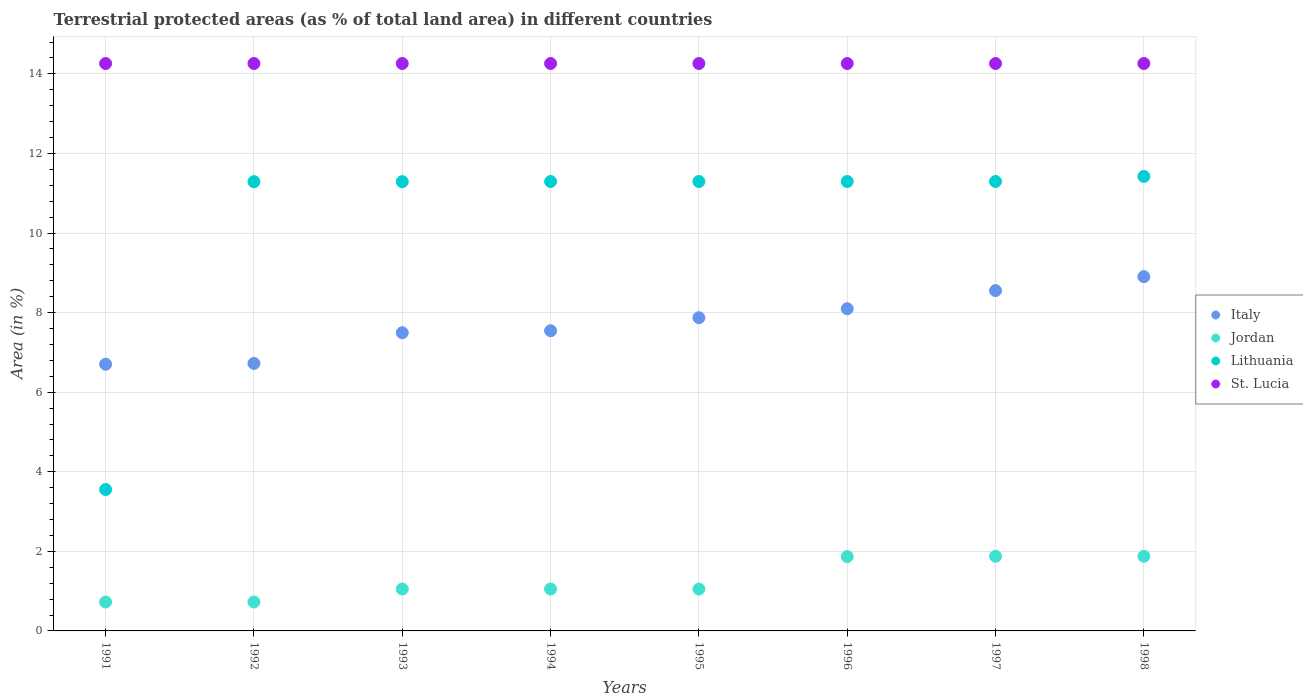How many different coloured dotlines are there?
Your answer should be compact. 4. What is the percentage of terrestrial protected land in Jordan in 1996?
Give a very brief answer. 1.87. Across all years, what is the maximum percentage of terrestrial protected land in St. Lucia?
Ensure brevity in your answer.  14.26. Across all years, what is the minimum percentage of terrestrial protected land in St. Lucia?
Keep it short and to the point. 14.26. In which year was the percentage of terrestrial protected land in Jordan minimum?
Offer a terse response. 1991. What is the total percentage of terrestrial protected land in Italy in the graph?
Give a very brief answer. 61.89. What is the difference between the percentage of terrestrial protected land in St. Lucia in 1991 and that in 1997?
Offer a terse response. 0. What is the difference between the percentage of terrestrial protected land in St. Lucia in 1993 and the percentage of terrestrial protected land in Jordan in 1992?
Provide a short and direct response. 13.53. What is the average percentage of terrestrial protected land in Italy per year?
Give a very brief answer. 7.74. In the year 1996, what is the difference between the percentage of terrestrial protected land in Jordan and percentage of terrestrial protected land in Italy?
Provide a succinct answer. -6.23. What is the ratio of the percentage of terrestrial protected land in Italy in 1992 to that in 1994?
Your response must be concise. 0.89. Is the percentage of terrestrial protected land in St. Lucia in 1991 less than that in 1993?
Offer a terse response. No. What is the difference between the highest and the lowest percentage of terrestrial protected land in Lithuania?
Provide a succinct answer. 7.87. In how many years, is the percentage of terrestrial protected land in Lithuania greater than the average percentage of terrestrial protected land in Lithuania taken over all years?
Offer a terse response. 7. Is the sum of the percentage of terrestrial protected land in St. Lucia in 1991 and 1998 greater than the maximum percentage of terrestrial protected land in Lithuania across all years?
Your response must be concise. Yes. Is it the case that in every year, the sum of the percentage of terrestrial protected land in St. Lucia and percentage of terrestrial protected land in Jordan  is greater than the sum of percentage of terrestrial protected land in Italy and percentage of terrestrial protected land in Lithuania?
Provide a succinct answer. Yes. Is it the case that in every year, the sum of the percentage of terrestrial protected land in Jordan and percentage of terrestrial protected land in Lithuania  is greater than the percentage of terrestrial protected land in St. Lucia?
Your answer should be compact. No. Is the percentage of terrestrial protected land in Jordan strictly greater than the percentage of terrestrial protected land in Italy over the years?
Make the answer very short. No. Is the percentage of terrestrial protected land in St. Lucia strictly less than the percentage of terrestrial protected land in Lithuania over the years?
Provide a succinct answer. No. How many dotlines are there?
Offer a terse response. 4. Are the values on the major ticks of Y-axis written in scientific E-notation?
Ensure brevity in your answer.  No. Does the graph contain any zero values?
Give a very brief answer. No. Does the graph contain grids?
Offer a terse response. Yes. Where does the legend appear in the graph?
Keep it short and to the point. Center right. What is the title of the graph?
Make the answer very short. Terrestrial protected areas (as % of total land area) in different countries. Does "Pakistan" appear as one of the legend labels in the graph?
Offer a terse response. No. What is the label or title of the Y-axis?
Your answer should be very brief. Area (in %). What is the Area (in %) in Italy in 1991?
Your answer should be compact. 6.7. What is the Area (in %) of Jordan in 1991?
Your answer should be compact. 0.73. What is the Area (in %) of Lithuania in 1991?
Provide a short and direct response. 3.55. What is the Area (in %) of St. Lucia in 1991?
Make the answer very short. 14.26. What is the Area (in %) of Italy in 1992?
Ensure brevity in your answer.  6.72. What is the Area (in %) of Jordan in 1992?
Offer a very short reply. 0.73. What is the Area (in %) in Lithuania in 1992?
Your response must be concise. 11.29. What is the Area (in %) in St. Lucia in 1992?
Offer a terse response. 14.26. What is the Area (in %) in Italy in 1993?
Provide a short and direct response. 7.49. What is the Area (in %) of Jordan in 1993?
Keep it short and to the point. 1.05. What is the Area (in %) in Lithuania in 1993?
Provide a succinct answer. 11.29. What is the Area (in %) of St. Lucia in 1993?
Your answer should be very brief. 14.26. What is the Area (in %) in Italy in 1994?
Your answer should be compact. 7.54. What is the Area (in %) in Jordan in 1994?
Make the answer very short. 1.05. What is the Area (in %) of Lithuania in 1994?
Provide a short and direct response. 11.29. What is the Area (in %) of St. Lucia in 1994?
Provide a succinct answer. 14.26. What is the Area (in %) in Italy in 1995?
Offer a very short reply. 7.87. What is the Area (in %) of Jordan in 1995?
Offer a very short reply. 1.05. What is the Area (in %) of Lithuania in 1995?
Offer a terse response. 11.29. What is the Area (in %) in St. Lucia in 1995?
Your answer should be compact. 14.26. What is the Area (in %) in Italy in 1996?
Your answer should be very brief. 8.1. What is the Area (in %) in Jordan in 1996?
Your answer should be compact. 1.87. What is the Area (in %) of Lithuania in 1996?
Offer a very short reply. 11.29. What is the Area (in %) in St. Lucia in 1996?
Your answer should be very brief. 14.26. What is the Area (in %) in Italy in 1997?
Your answer should be compact. 8.55. What is the Area (in %) of Jordan in 1997?
Provide a succinct answer. 1.88. What is the Area (in %) in Lithuania in 1997?
Provide a short and direct response. 11.29. What is the Area (in %) of St. Lucia in 1997?
Your response must be concise. 14.26. What is the Area (in %) of Italy in 1998?
Offer a terse response. 8.9. What is the Area (in %) in Jordan in 1998?
Keep it short and to the point. 1.88. What is the Area (in %) of Lithuania in 1998?
Your answer should be compact. 11.42. What is the Area (in %) in St. Lucia in 1998?
Offer a terse response. 14.26. Across all years, what is the maximum Area (in %) of Italy?
Offer a terse response. 8.9. Across all years, what is the maximum Area (in %) of Jordan?
Your response must be concise. 1.88. Across all years, what is the maximum Area (in %) in Lithuania?
Your response must be concise. 11.42. Across all years, what is the maximum Area (in %) in St. Lucia?
Offer a terse response. 14.26. Across all years, what is the minimum Area (in %) of Italy?
Ensure brevity in your answer.  6.7. Across all years, what is the minimum Area (in %) in Jordan?
Provide a succinct answer. 0.73. Across all years, what is the minimum Area (in %) of Lithuania?
Your answer should be very brief. 3.55. Across all years, what is the minimum Area (in %) of St. Lucia?
Offer a terse response. 14.26. What is the total Area (in %) in Italy in the graph?
Make the answer very short. 61.89. What is the total Area (in %) of Jordan in the graph?
Your answer should be compact. 10.23. What is the total Area (in %) of Lithuania in the graph?
Your answer should be very brief. 82.73. What is the total Area (in %) of St. Lucia in the graph?
Provide a succinct answer. 114.08. What is the difference between the Area (in %) of Italy in 1991 and that in 1992?
Make the answer very short. -0.02. What is the difference between the Area (in %) of Jordan in 1991 and that in 1992?
Make the answer very short. 0. What is the difference between the Area (in %) in Lithuania in 1991 and that in 1992?
Give a very brief answer. -7.74. What is the difference between the Area (in %) in Italy in 1991 and that in 1993?
Your answer should be very brief. -0.79. What is the difference between the Area (in %) in Jordan in 1991 and that in 1993?
Provide a succinct answer. -0.33. What is the difference between the Area (in %) in Lithuania in 1991 and that in 1993?
Keep it short and to the point. -7.74. What is the difference between the Area (in %) in St. Lucia in 1991 and that in 1993?
Your response must be concise. 0. What is the difference between the Area (in %) in Italy in 1991 and that in 1994?
Make the answer very short. -0.84. What is the difference between the Area (in %) in Jordan in 1991 and that in 1994?
Provide a short and direct response. -0.33. What is the difference between the Area (in %) in Lithuania in 1991 and that in 1994?
Your answer should be very brief. -7.74. What is the difference between the Area (in %) in Italy in 1991 and that in 1995?
Your answer should be very brief. -1.17. What is the difference between the Area (in %) in Jordan in 1991 and that in 1995?
Keep it short and to the point. -0.33. What is the difference between the Area (in %) in Lithuania in 1991 and that in 1995?
Provide a short and direct response. -7.74. What is the difference between the Area (in %) in Italy in 1991 and that in 1996?
Offer a very short reply. -1.39. What is the difference between the Area (in %) of Jordan in 1991 and that in 1996?
Offer a terse response. -1.14. What is the difference between the Area (in %) of Lithuania in 1991 and that in 1996?
Offer a very short reply. -7.74. What is the difference between the Area (in %) in St. Lucia in 1991 and that in 1996?
Offer a very short reply. 0. What is the difference between the Area (in %) of Italy in 1991 and that in 1997?
Give a very brief answer. -1.85. What is the difference between the Area (in %) of Jordan in 1991 and that in 1997?
Your answer should be very brief. -1.15. What is the difference between the Area (in %) of Lithuania in 1991 and that in 1997?
Provide a succinct answer. -7.74. What is the difference between the Area (in %) of Italy in 1991 and that in 1998?
Your answer should be compact. -2.2. What is the difference between the Area (in %) of Jordan in 1991 and that in 1998?
Your answer should be very brief. -1.15. What is the difference between the Area (in %) in Lithuania in 1991 and that in 1998?
Make the answer very short. -7.87. What is the difference between the Area (in %) in St. Lucia in 1991 and that in 1998?
Offer a terse response. 0. What is the difference between the Area (in %) of Italy in 1992 and that in 1993?
Make the answer very short. -0.77. What is the difference between the Area (in %) in Jordan in 1992 and that in 1993?
Keep it short and to the point. -0.33. What is the difference between the Area (in %) in St. Lucia in 1992 and that in 1993?
Offer a terse response. 0. What is the difference between the Area (in %) of Italy in 1992 and that in 1994?
Offer a very short reply. -0.82. What is the difference between the Area (in %) in Jordan in 1992 and that in 1994?
Keep it short and to the point. -0.33. What is the difference between the Area (in %) in Lithuania in 1992 and that in 1994?
Your response must be concise. -0. What is the difference between the Area (in %) in St. Lucia in 1992 and that in 1994?
Provide a short and direct response. 0. What is the difference between the Area (in %) of Italy in 1992 and that in 1995?
Provide a succinct answer. -1.15. What is the difference between the Area (in %) of Jordan in 1992 and that in 1995?
Provide a succinct answer. -0.33. What is the difference between the Area (in %) in Lithuania in 1992 and that in 1995?
Your answer should be compact. -0. What is the difference between the Area (in %) of St. Lucia in 1992 and that in 1995?
Give a very brief answer. 0. What is the difference between the Area (in %) of Italy in 1992 and that in 1996?
Provide a succinct answer. -1.37. What is the difference between the Area (in %) in Jordan in 1992 and that in 1996?
Provide a succinct answer. -1.14. What is the difference between the Area (in %) in Lithuania in 1992 and that in 1996?
Offer a terse response. -0. What is the difference between the Area (in %) in St. Lucia in 1992 and that in 1996?
Offer a very short reply. 0. What is the difference between the Area (in %) of Italy in 1992 and that in 1997?
Offer a very short reply. -1.83. What is the difference between the Area (in %) of Jordan in 1992 and that in 1997?
Give a very brief answer. -1.15. What is the difference between the Area (in %) in Lithuania in 1992 and that in 1997?
Offer a terse response. -0. What is the difference between the Area (in %) of Italy in 1992 and that in 1998?
Your answer should be compact. -2.18. What is the difference between the Area (in %) in Jordan in 1992 and that in 1998?
Your answer should be compact. -1.15. What is the difference between the Area (in %) in Lithuania in 1992 and that in 1998?
Provide a short and direct response. -0.13. What is the difference between the Area (in %) of Italy in 1993 and that in 1994?
Your answer should be very brief. -0.05. What is the difference between the Area (in %) of Jordan in 1993 and that in 1994?
Provide a short and direct response. 0. What is the difference between the Area (in %) in Lithuania in 1993 and that in 1994?
Your answer should be very brief. -0. What is the difference between the Area (in %) of Italy in 1993 and that in 1995?
Your answer should be very brief. -0.38. What is the difference between the Area (in %) in Jordan in 1993 and that in 1995?
Your response must be concise. 0. What is the difference between the Area (in %) in Lithuania in 1993 and that in 1995?
Give a very brief answer. -0. What is the difference between the Area (in %) of St. Lucia in 1993 and that in 1995?
Make the answer very short. 0. What is the difference between the Area (in %) in Italy in 1993 and that in 1996?
Offer a very short reply. -0.6. What is the difference between the Area (in %) of Jordan in 1993 and that in 1996?
Your answer should be very brief. -0.82. What is the difference between the Area (in %) in Lithuania in 1993 and that in 1996?
Provide a short and direct response. -0. What is the difference between the Area (in %) in Italy in 1993 and that in 1997?
Make the answer very short. -1.06. What is the difference between the Area (in %) of Jordan in 1993 and that in 1997?
Provide a succinct answer. -0.82. What is the difference between the Area (in %) of Lithuania in 1993 and that in 1997?
Make the answer very short. -0. What is the difference between the Area (in %) in Italy in 1993 and that in 1998?
Your answer should be compact. -1.41. What is the difference between the Area (in %) of Jordan in 1993 and that in 1998?
Ensure brevity in your answer.  -0.82. What is the difference between the Area (in %) in Lithuania in 1993 and that in 1998?
Keep it short and to the point. -0.13. What is the difference between the Area (in %) in St. Lucia in 1993 and that in 1998?
Offer a terse response. 0. What is the difference between the Area (in %) of Italy in 1994 and that in 1995?
Offer a terse response. -0.33. What is the difference between the Area (in %) in Jordan in 1994 and that in 1995?
Ensure brevity in your answer.  0. What is the difference between the Area (in %) of Lithuania in 1994 and that in 1995?
Provide a short and direct response. 0. What is the difference between the Area (in %) in St. Lucia in 1994 and that in 1995?
Your answer should be very brief. 0. What is the difference between the Area (in %) in Italy in 1994 and that in 1996?
Keep it short and to the point. -0.55. What is the difference between the Area (in %) in Jordan in 1994 and that in 1996?
Ensure brevity in your answer.  -0.82. What is the difference between the Area (in %) of Lithuania in 1994 and that in 1996?
Offer a very short reply. 0. What is the difference between the Area (in %) in St. Lucia in 1994 and that in 1996?
Offer a terse response. 0. What is the difference between the Area (in %) of Italy in 1994 and that in 1997?
Provide a short and direct response. -1.01. What is the difference between the Area (in %) in Jordan in 1994 and that in 1997?
Offer a terse response. -0.82. What is the difference between the Area (in %) of Lithuania in 1994 and that in 1997?
Offer a very short reply. 0. What is the difference between the Area (in %) of St. Lucia in 1994 and that in 1997?
Ensure brevity in your answer.  0. What is the difference between the Area (in %) of Italy in 1994 and that in 1998?
Make the answer very short. -1.36. What is the difference between the Area (in %) in Jordan in 1994 and that in 1998?
Offer a terse response. -0.82. What is the difference between the Area (in %) in Lithuania in 1994 and that in 1998?
Your answer should be very brief. -0.13. What is the difference between the Area (in %) in St. Lucia in 1994 and that in 1998?
Provide a short and direct response. 0. What is the difference between the Area (in %) in Italy in 1995 and that in 1996?
Your answer should be very brief. -0.23. What is the difference between the Area (in %) of Jordan in 1995 and that in 1996?
Give a very brief answer. -0.82. What is the difference between the Area (in %) of Lithuania in 1995 and that in 1996?
Make the answer very short. 0. What is the difference between the Area (in %) in Italy in 1995 and that in 1997?
Provide a short and direct response. -0.68. What is the difference between the Area (in %) of Jordan in 1995 and that in 1997?
Provide a succinct answer. -0.82. What is the difference between the Area (in %) in Lithuania in 1995 and that in 1997?
Ensure brevity in your answer.  0. What is the difference between the Area (in %) in Italy in 1995 and that in 1998?
Give a very brief answer. -1.03. What is the difference between the Area (in %) of Jordan in 1995 and that in 1998?
Keep it short and to the point. -0.82. What is the difference between the Area (in %) of Lithuania in 1995 and that in 1998?
Your response must be concise. -0.13. What is the difference between the Area (in %) of St. Lucia in 1995 and that in 1998?
Your response must be concise. 0. What is the difference between the Area (in %) of Italy in 1996 and that in 1997?
Keep it short and to the point. -0.46. What is the difference between the Area (in %) of Jordan in 1996 and that in 1997?
Your response must be concise. -0.01. What is the difference between the Area (in %) of Lithuania in 1996 and that in 1997?
Provide a succinct answer. -0. What is the difference between the Area (in %) of St. Lucia in 1996 and that in 1997?
Provide a succinct answer. 0. What is the difference between the Area (in %) in Italy in 1996 and that in 1998?
Your answer should be very brief. -0.81. What is the difference between the Area (in %) of Jordan in 1996 and that in 1998?
Offer a very short reply. -0.01. What is the difference between the Area (in %) in Lithuania in 1996 and that in 1998?
Make the answer very short. -0.13. What is the difference between the Area (in %) in St. Lucia in 1996 and that in 1998?
Ensure brevity in your answer.  0. What is the difference between the Area (in %) of Italy in 1997 and that in 1998?
Offer a very short reply. -0.35. What is the difference between the Area (in %) of Jordan in 1997 and that in 1998?
Ensure brevity in your answer.  0. What is the difference between the Area (in %) of Lithuania in 1997 and that in 1998?
Give a very brief answer. -0.13. What is the difference between the Area (in %) of St. Lucia in 1997 and that in 1998?
Your answer should be compact. 0. What is the difference between the Area (in %) in Italy in 1991 and the Area (in %) in Jordan in 1992?
Your answer should be very brief. 5.98. What is the difference between the Area (in %) in Italy in 1991 and the Area (in %) in Lithuania in 1992?
Provide a succinct answer. -4.59. What is the difference between the Area (in %) in Italy in 1991 and the Area (in %) in St. Lucia in 1992?
Provide a short and direct response. -7.56. What is the difference between the Area (in %) in Jordan in 1991 and the Area (in %) in Lithuania in 1992?
Ensure brevity in your answer.  -10.56. What is the difference between the Area (in %) of Jordan in 1991 and the Area (in %) of St. Lucia in 1992?
Your answer should be very brief. -13.53. What is the difference between the Area (in %) in Lithuania in 1991 and the Area (in %) in St. Lucia in 1992?
Give a very brief answer. -10.71. What is the difference between the Area (in %) in Italy in 1991 and the Area (in %) in Jordan in 1993?
Give a very brief answer. 5.65. What is the difference between the Area (in %) of Italy in 1991 and the Area (in %) of Lithuania in 1993?
Offer a very short reply. -4.59. What is the difference between the Area (in %) of Italy in 1991 and the Area (in %) of St. Lucia in 1993?
Keep it short and to the point. -7.56. What is the difference between the Area (in %) in Jordan in 1991 and the Area (in %) in Lithuania in 1993?
Your response must be concise. -10.56. What is the difference between the Area (in %) of Jordan in 1991 and the Area (in %) of St. Lucia in 1993?
Provide a succinct answer. -13.53. What is the difference between the Area (in %) in Lithuania in 1991 and the Area (in %) in St. Lucia in 1993?
Offer a terse response. -10.71. What is the difference between the Area (in %) in Italy in 1991 and the Area (in %) in Jordan in 1994?
Offer a terse response. 5.65. What is the difference between the Area (in %) of Italy in 1991 and the Area (in %) of Lithuania in 1994?
Give a very brief answer. -4.59. What is the difference between the Area (in %) of Italy in 1991 and the Area (in %) of St. Lucia in 1994?
Provide a short and direct response. -7.56. What is the difference between the Area (in %) in Jordan in 1991 and the Area (in %) in Lithuania in 1994?
Provide a short and direct response. -10.57. What is the difference between the Area (in %) of Jordan in 1991 and the Area (in %) of St. Lucia in 1994?
Your answer should be very brief. -13.53. What is the difference between the Area (in %) in Lithuania in 1991 and the Area (in %) in St. Lucia in 1994?
Keep it short and to the point. -10.71. What is the difference between the Area (in %) in Italy in 1991 and the Area (in %) in Jordan in 1995?
Offer a terse response. 5.65. What is the difference between the Area (in %) in Italy in 1991 and the Area (in %) in Lithuania in 1995?
Ensure brevity in your answer.  -4.59. What is the difference between the Area (in %) in Italy in 1991 and the Area (in %) in St. Lucia in 1995?
Make the answer very short. -7.56. What is the difference between the Area (in %) of Jordan in 1991 and the Area (in %) of Lithuania in 1995?
Keep it short and to the point. -10.57. What is the difference between the Area (in %) in Jordan in 1991 and the Area (in %) in St. Lucia in 1995?
Provide a short and direct response. -13.53. What is the difference between the Area (in %) of Lithuania in 1991 and the Area (in %) of St. Lucia in 1995?
Ensure brevity in your answer.  -10.71. What is the difference between the Area (in %) of Italy in 1991 and the Area (in %) of Jordan in 1996?
Your answer should be compact. 4.83. What is the difference between the Area (in %) in Italy in 1991 and the Area (in %) in Lithuania in 1996?
Make the answer very short. -4.59. What is the difference between the Area (in %) of Italy in 1991 and the Area (in %) of St. Lucia in 1996?
Offer a very short reply. -7.56. What is the difference between the Area (in %) of Jordan in 1991 and the Area (in %) of Lithuania in 1996?
Provide a succinct answer. -10.57. What is the difference between the Area (in %) in Jordan in 1991 and the Area (in %) in St. Lucia in 1996?
Your response must be concise. -13.53. What is the difference between the Area (in %) in Lithuania in 1991 and the Area (in %) in St. Lucia in 1996?
Give a very brief answer. -10.71. What is the difference between the Area (in %) in Italy in 1991 and the Area (in %) in Jordan in 1997?
Provide a short and direct response. 4.83. What is the difference between the Area (in %) of Italy in 1991 and the Area (in %) of Lithuania in 1997?
Offer a very short reply. -4.59. What is the difference between the Area (in %) in Italy in 1991 and the Area (in %) in St. Lucia in 1997?
Ensure brevity in your answer.  -7.56. What is the difference between the Area (in %) in Jordan in 1991 and the Area (in %) in Lithuania in 1997?
Your response must be concise. -10.57. What is the difference between the Area (in %) in Jordan in 1991 and the Area (in %) in St. Lucia in 1997?
Provide a succinct answer. -13.53. What is the difference between the Area (in %) of Lithuania in 1991 and the Area (in %) of St. Lucia in 1997?
Offer a very short reply. -10.71. What is the difference between the Area (in %) of Italy in 1991 and the Area (in %) of Jordan in 1998?
Keep it short and to the point. 4.83. What is the difference between the Area (in %) of Italy in 1991 and the Area (in %) of Lithuania in 1998?
Provide a succinct answer. -4.72. What is the difference between the Area (in %) of Italy in 1991 and the Area (in %) of St. Lucia in 1998?
Provide a short and direct response. -7.56. What is the difference between the Area (in %) of Jordan in 1991 and the Area (in %) of Lithuania in 1998?
Your response must be concise. -10.69. What is the difference between the Area (in %) of Jordan in 1991 and the Area (in %) of St. Lucia in 1998?
Your answer should be very brief. -13.53. What is the difference between the Area (in %) in Lithuania in 1991 and the Area (in %) in St. Lucia in 1998?
Make the answer very short. -10.71. What is the difference between the Area (in %) of Italy in 1992 and the Area (in %) of Jordan in 1993?
Your answer should be very brief. 5.67. What is the difference between the Area (in %) in Italy in 1992 and the Area (in %) in Lithuania in 1993?
Provide a succinct answer. -4.57. What is the difference between the Area (in %) in Italy in 1992 and the Area (in %) in St. Lucia in 1993?
Ensure brevity in your answer.  -7.54. What is the difference between the Area (in %) of Jordan in 1992 and the Area (in %) of Lithuania in 1993?
Your answer should be very brief. -10.56. What is the difference between the Area (in %) in Jordan in 1992 and the Area (in %) in St. Lucia in 1993?
Give a very brief answer. -13.53. What is the difference between the Area (in %) of Lithuania in 1992 and the Area (in %) of St. Lucia in 1993?
Your answer should be very brief. -2.97. What is the difference between the Area (in %) in Italy in 1992 and the Area (in %) in Jordan in 1994?
Your answer should be compact. 5.67. What is the difference between the Area (in %) in Italy in 1992 and the Area (in %) in Lithuania in 1994?
Provide a succinct answer. -4.57. What is the difference between the Area (in %) in Italy in 1992 and the Area (in %) in St. Lucia in 1994?
Your answer should be very brief. -7.54. What is the difference between the Area (in %) in Jordan in 1992 and the Area (in %) in Lithuania in 1994?
Ensure brevity in your answer.  -10.57. What is the difference between the Area (in %) in Jordan in 1992 and the Area (in %) in St. Lucia in 1994?
Offer a terse response. -13.53. What is the difference between the Area (in %) of Lithuania in 1992 and the Area (in %) of St. Lucia in 1994?
Offer a very short reply. -2.97. What is the difference between the Area (in %) in Italy in 1992 and the Area (in %) in Jordan in 1995?
Make the answer very short. 5.67. What is the difference between the Area (in %) in Italy in 1992 and the Area (in %) in Lithuania in 1995?
Provide a short and direct response. -4.57. What is the difference between the Area (in %) of Italy in 1992 and the Area (in %) of St. Lucia in 1995?
Provide a short and direct response. -7.54. What is the difference between the Area (in %) of Jordan in 1992 and the Area (in %) of Lithuania in 1995?
Your response must be concise. -10.57. What is the difference between the Area (in %) in Jordan in 1992 and the Area (in %) in St. Lucia in 1995?
Keep it short and to the point. -13.53. What is the difference between the Area (in %) of Lithuania in 1992 and the Area (in %) of St. Lucia in 1995?
Your answer should be very brief. -2.97. What is the difference between the Area (in %) in Italy in 1992 and the Area (in %) in Jordan in 1996?
Provide a succinct answer. 4.85. What is the difference between the Area (in %) in Italy in 1992 and the Area (in %) in Lithuania in 1996?
Provide a short and direct response. -4.57. What is the difference between the Area (in %) in Italy in 1992 and the Area (in %) in St. Lucia in 1996?
Keep it short and to the point. -7.54. What is the difference between the Area (in %) of Jordan in 1992 and the Area (in %) of Lithuania in 1996?
Give a very brief answer. -10.57. What is the difference between the Area (in %) in Jordan in 1992 and the Area (in %) in St. Lucia in 1996?
Keep it short and to the point. -13.53. What is the difference between the Area (in %) of Lithuania in 1992 and the Area (in %) of St. Lucia in 1996?
Keep it short and to the point. -2.97. What is the difference between the Area (in %) in Italy in 1992 and the Area (in %) in Jordan in 1997?
Your answer should be very brief. 4.85. What is the difference between the Area (in %) of Italy in 1992 and the Area (in %) of Lithuania in 1997?
Provide a short and direct response. -4.57. What is the difference between the Area (in %) in Italy in 1992 and the Area (in %) in St. Lucia in 1997?
Provide a short and direct response. -7.54. What is the difference between the Area (in %) in Jordan in 1992 and the Area (in %) in Lithuania in 1997?
Your answer should be very brief. -10.57. What is the difference between the Area (in %) in Jordan in 1992 and the Area (in %) in St. Lucia in 1997?
Provide a succinct answer. -13.53. What is the difference between the Area (in %) of Lithuania in 1992 and the Area (in %) of St. Lucia in 1997?
Your answer should be very brief. -2.97. What is the difference between the Area (in %) in Italy in 1992 and the Area (in %) in Jordan in 1998?
Your response must be concise. 4.85. What is the difference between the Area (in %) in Italy in 1992 and the Area (in %) in Lithuania in 1998?
Your answer should be compact. -4.7. What is the difference between the Area (in %) of Italy in 1992 and the Area (in %) of St. Lucia in 1998?
Ensure brevity in your answer.  -7.54. What is the difference between the Area (in %) in Jordan in 1992 and the Area (in %) in Lithuania in 1998?
Make the answer very short. -10.69. What is the difference between the Area (in %) of Jordan in 1992 and the Area (in %) of St. Lucia in 1998?
Provide a succinct answer. -13.53. What is the difference between the Area (in %) of Lithuania in 1992 and the Area (in %) of St. Lucia in 1998?
Ensure brevity in your answer.  -2.97. What is the difference between the Area (in %) of Italy in 1993 and the Area (in %) of Jordan in 1994?
Your answer should be compact. 6.44. What is the difference between the Area (in %) in Italy in 1993 and the Area (in %) in Lithuania in 1994?
Provide a short and direct response. -3.8. What is the difference between the Area (in %) in Italy in 1993 and the Area (in %) in St. Lucia in 1994?
Give a very brief answer. -6.77. What is the difference between the Area (in %) of Jordan in 1993 and the Area (in %) of Lithuania in 1994?
Ensure brevity in your answer.  -10.24. What is the difference between the Area (in %) of Jordan in 1993 and the Area (in %) of St. Lucia in 1994?
Offer a terse response. -13.21. What is the difference between the Area (in %) in Lithuania in 1993 and the Area (in %) in St. Lucia in 1994?
Ensure brevity in your answer.  -2.97. What is the difference between the Area (in %) of Italy in 1993 and the Area (in %) of Jordan in 1995?
Offer a very short reply. 6.44. What is the difference between the Area (in %) in Italy in 1993 and the Area (in %) in Lithuania in 1995?
Provide a succinct answer. -3.8. What is the difference between the Area (in %) of Italy in 1993 and the Area (in %) of St. Lucia in 1995?
Your answer should be very brief. -6.77. What is the difference between the Area (in %) in Jordan in 1993 and the Area (in %) in Lithuania in 1995?
Ensure brevity in your answer.  -10.24. What is the difference between the Area (in %) of Jordan in 1993 and the Area (in %) of St. Lucia in 1995?
Your response must be concise. -13.21. What is the difference between the Area (in %) of Lithuania in 1993 and the Area (in %) of St. Lucia in 1995?
Ensure brevity in your answer.  -2.97. What is the difference between the Area (in %) in Italy in 1993 and the Area (in %) in Jordan in 1996?
Offer a very short reply. 5.63. What is the difference between the Area (in %) in Italy in 1993 and the Area (in %) in Lithuania in 1996?
Provide a succinct answer. -3.8. What is the difference between the Area (in %) of Italy in 1993 and the Area (in %) of St. Lucia in 1996?
Your answer should be compact. -6.77. What is the difference between the Area (in %) of Jordan in 1993 and the Area (in %) of Lithuania in 1996?
Offer a very short reply. -10.24. What is the difference between the Area (in %) in Jordan in 1993 and the Area (in %) in St. Lucia in 1996?
Give a very brief answer. -13.21. What is the difference between the Area (in %) of Lithuania in 1993 and the Area (in %) of St. Lucia in 1996?
Ensure brevity in your answer.  -2.97. What is the difference between the Area (in %) of Italy in 1993 and the Area (in %) of Jordan in 1997?
Your answer should be very brief. 5.62. What is the difference between the Area (in %) of Italy in 1993 and the Area (in %) of Lithuania in 1997?
Provide a short and direct response. -3.8. What is the difference between the Area (in %) in Italy in 1993 and the Area (in %) in St. Lucia in 1997?
Offer a terse response. -6.77. What is the difference between the Area (in %) in Jordan in 1993 and the Area (in %) in Lithuania in 1997?
Make the answer very short. -10.24. What is the difference between the Area (in %) of Jordan in 1993 and the Area (in %) of St. Lucia in 1997?
Your answer should be compact. -13.21. What is the difference between the Area (in %) in Lithuania in 1993 and the Area (in %) in St. Lucia in 1997?
Provide a succinct answer. -2.97. What is the difference between the Area (in %) of Italy in 1993 and the Area (in %) of Jordan in 1998?
Ensure brevity in your answer.  5.62. What is the difference between the Area (in %) of Italy in 1993 and the Area (in %) of Lithuania in 1998?
Give a very brief answer. -3.93. What is the difference between the Area (in %) of Italy in 1993 and the Area (in %) of St. Lucia in 1998?
Your answer should be very brief. -6.77. What is the difference between the Area (in %) in Jordan in 1993 and the Area (in %) in Lithuania in 1998?
Give a very brief answer. -10.37. What is the difference between the Area (in %) in Jordan in 1993 and the Area (in %) in St. Lucia in 1998?
Provide a short and direct response. -13.21. What is the difference between the Area (in %) in Lithuania in 1993 and the Area (in %) in St. Lucia in 1998?
Your response must be concise. -2.97. What is the difference between the Area (in %) of Italy in 1994 and the Area (in %) of Jordan in 1995?
Ensure brevity in your answer.  6.49. What is the difference between the Area (in %) of Italy in 1994 and the Area (in %) of Lithuania in 1995?
Offer a terse response. -3.75. What is the difference between the Area (in %) of Italy in 1994 and the Area (in %) of St. Lucia in 1995?
Make the answer very short. -6.72. What is the difference between the Area (in %) of Jordan in 1994 and the Area (in %) of Lithuania in 1995?
Give a very brief answer. -10.24. What is the difference between the Area (in %) in Jordan in 1994 and the Area (in %) in St. Lucia in 1995?
Provide a short and direct response. -13.21. What is the difference between the Area (in %) in Lithuania in 1994 and the Area (in %) in St. Lucia in 1995?
Your answer should be very brief. -2.97. What is the difference between the Area (in %) in Italy in 1994 and the Area (in %) in Jordan in 1996?
Your answer should be very brief. 5.68. What is the difference between the Area (in %) of Italy in 1994 and the Area (in %) of Lithuania in 1996?
Keep it short and to the point. -3.75. What is the difference between the Area (in %) in Italy in 1994 and the Area (in %) in St. Lucia in 1996?
Provide a short and direct response. -6.72. What is the difference between the Area (in %) in Jordan in 1994 and the Area (in %) in Lithuania in 1996?
Provide a short and direct response. -10.24. What is the difference between the Area (in %) in Jordan in 1994 and the Area (in %) in St. Lucia in 1996?
Your answer should be very brief. -13.21. What is the difference between the Area (in %) in Lithuania in 1994 and the Area (in %) in St. Lucia in 1996?
Provide a succinct answer. -2.97. What is the difference between the Area (in %) of Italy in 1994 and the Area (in %) of Jordan in 1997?
Ensure brevity in your answer.  5.67. What is the difference between the Area (in %) of Italy in 1994 and the Area (in %) of Lithuania in 1997?
Make the answer very short. -3.75. What is the difference between the Area (in %) of Italy in 1994 and the Area (in %) of St. Lucia in 1997?
Your answer should be very brief. -6.72. What is the difference between the Area (in %) of Jordan in 1994 and the Area (in %) of Lithuania in 1997?
Provide a short and direct response. -10.24. What is the difference between the Area (in %) of Jordan in 1994 and the Area (in %) of St. Lucia in 1997?
Your answer should be compact. -13.21. What is the difference between the Area (in %) of Lithuania in 1994 and the Area (in %) of St. Lucia in 1997?
Offer a terse response. -2.97. What is the difference between the Area (in %) of Italy in 1994 and the Area (in %) of Jordan in 1998?
Keep it short and to the point. 5.67. What is the difference between the Area (in %) in Italy in 1994 and the Area (in %) in Lithuania in 1998?
Provide a short and direct response. -3.88. What is the difference between the Area (in %) of Italy in 1994 and the Area (in %) of St. Lucia in 1998?
Offer a terse response. -6.72. What is the difference between the Area (in %) in Jordan in 1994 and the Area (in %) in Lithuania in 1998?
Offer a terse response. -10.37. What is the difference between the Area (in %) in Jordan in 1994 and the Area (in %) in St. Lucia in 1998?
Offer a terse response. -13.21. What is the difference between the Area (in %) of Lithuania in 1994 and the Area (in %) of St. Lucia in 1998?
Your answer should be very brief. -2.97. What is the difference between the Area (in %) of Italy in 1995 and the Area (in %) of Jordan in 1996?
Your response must be concise. 6. What is the difference between the Area (in %) of Italy in 1995 and the Area (in %) of Lithuania in 1996?
Offer a terse response. -3.42. What is the difference between the Area (in %) in Italy in 1995 and the Area (in %) in St. Lucia in 1996?
Keep it short and to the point. -6.39. What is the difference between the Area (in %) in Jordan in 1995 and the Area (in %) in Lithuania in 1996?
Offer a terse response. -10.24. What is the difference between the Area (in %) in Jordan in 1995 and the Area (in %) in St. Lucia in 1996?
Ensure brevity in your answer.  -13.21. What is the difference between the Area (in %) in Lithuania in 1995 and the Area (in %) in St. Lucia in 1996?
Provide a short and direct response. -2.97. What is the difference between the Area (in %) of Italy in 1995 and the Area (in %) of Jordan in 1997?
Your answer should be compact. 6. What is the difference between the Area (in %) of Italy in 1995 and the Area (in %) of Lithuania in 1997?
Provide a succinct answer. -3.42. What is the difference between the Area (in %) in Italy in 1995 and the Area (in %) in St. Lucia in 1997?
Offer a very short reply. -6.39. What is the difference between the Area (in %) in Jordan in 1995 and the Area (in %) in Lithuania in 1997?
Provide a short and direct response. -10.24. What is the difference between the Area (in %) of Jordan in 1995 and the Area (in %) of St. Lucia in 1997?
Your response must be concise. -13.21. What is the difference between the Area (in %) in Lithuania in 1995 and the Area (in %) in St. Lucia in 1997?
Your response must be concise. -2.97. What is the difference between the Area (in %) in Italy in 1995 and the Area (in %) in Jordan in 1998?
Keep it short and to the point. 6. What is the difference between the Area (in %) in Italy in 1995 and the Area (in %) in Lithuania in 1998?
Your answer should be very brief. -3.55. What is the difference between the Area (in %) of Italy in 1995 and the Area (in %) of St. Lucia in 1998?
Your answer should be very brief. -6.39. What is the difference between the Area (in %) of Jordan in 1995 and the Area (in %) of Lithuania in 1998?
Provide a short and direct response. -10.37. What is the difference between the Area (in %) of Jordan in 1995 and the Area (in %) of St. Lucia in 1998?
Give a very brief answer. -13.21. What is the difference between the Area (in %) in Lithuania in 1995 and the Area (in %) in St. Lucia in 1998?
Make the answer very short. -2.97. What is the difference between the Area (in %) of Italy in 1996 and the Area (in %) of Jordan in 1997?
Give a very brief answer. 6.22. What is the difference between the Area (in %) in Italy in 1996 and the Area (in %) in Lithuania in 1997?
Make the answer very short. -3.2. What is the difference between the Area (in %) in Italy in 1996 and the Area (in %) in St. Lucia in 1997?
Give a very brief answer. -6.16. What is the difference between the Area (in %) in Jordan in 1996 and the Area (in %) in Lithuania in 1997?
Make the answer very short. -9.43. What is the difference between the Area (in %) in Jordan in 1996 and the Area (in %) in St. Lucia in 1997?
Your answer should be compact. -12.39. What is the difference between the Area (in %) of Lithuania in 1996 and the Area (in %) of St. Lucia in 1997?
Offer a terse response. -2.97. What is the difference between the Area (in %) in Italy in 1996 and the Area (in %) in Jordan in 1998?
Provide a short and direct response. 6.22. What is the difference between the Area (in %) in Italy in 1996 and the Area (in %) in Lithuania in 1998?
Offer a terse response. -3.32. What is the difference between the Area (in %) in Italy in 1996 and the Area (in %) in St. Lucia in 1998?
Offer a terse response. -6.16. What is the difference between the Area (in %) in Jordan in 1996 and the Area (in %) in Lithuania in 1998?
Keep it short and to the point. -9.55. What is the difference between the Area (in %) in Jordan in 1996 and the Area (in %) in St. Lucia in 1998?
Keep it short and to the point. -12.39. What is the difference between the Area (in %) in Lithuania in 1996 and the Area (in %) in St. Lucia in 1998?
Your response must be concise. -2.97. What is the difference between the Area (in %) of Italy in 1997 and the Area (in %) of Jordan in 1998?
Ensure brevity in your answer.  6.68. What is the difference between the Area (in %) of Italy in 1997 and the Area (in %) of Lithuania in 1998?
Provide a short and direct response. -2.87. What is the difference between the Area (in %) in Italy in 1997 and the Area (in %) in St. Lucia in 1998?
Provide a succinct answer. -5.71. What is the difference between the Area (in %) in Jordan in 1997 and the Area (in %) in Lithuania in 1998?
Make the answer very short. -9.55. What is the difference between the Area (in %) of Jordan in 1997 and the Area (in %) of St. Lucia in 1998?
Keep it short and to the point. -12.38. What is the difference between the Area (in %) in Lithuania in 1997 and the Area (in %) in St. Lucia in 1998?
Offer a terse response. -2.97. What is the average Area (in %) of Italy per year?
Provide a succinct answer. 7.74. What is the average Area (in %) in Jordan per year?
Your answer should be very brief. 1.28. What is the average Area (in %) in Lithuania per year?
Ensure brevity in your answer.  10.34. What is the average Area (in %) of St. Lucia per year?
Your answer should be very brief. 14.26. In the year 1991, what is the difference between the Area (in %) of Italy and Area (in %) of Jordan?
Provide a succinct answer. 5.98. In the year 1991, what is the difference between the Area (in %) of Italy and Area (in %) of Lithuania?
Keep it short and to the point. 3.15. In the year 1991, what is the difference between the Area (in %) of Italy and Area (in %) of St. Lucia?
Offer a terse response. -7.56. In the year 1991, what is the difference between the Area (in %) in Jordan and Area (in %) in Lithuania?
Provide a succinct answer. -2.83. In the year 1991, what is the difference between the Area (in %) of Jordan and Area (in %) of St. Lucia?
Keep it short and to the point. -13.53. In the year 1991, what is the difference between the Area (in %) in Lithuania and Area (in %) in St. Lucia?
Provide a succinct answer. -10.71. In the year 1992, what is the difference between the Area (in %) of Italy and Area (in %) of Jordan?
Provide a succinct answer. 6. In the year 1992, what is the difference between the Area (in %) in Italy and Area (in %) in Lithuania?
Provide a succinct answer. -4.57. In the year 1992, what is the difference between the Area (in %) of Italy and Area (in %) of St. Lucia?
Ensure brevity in your answer.  -7.54. In the year 1992, what is the difference between the Area (in %) in Jordan and Area (in %) in Lithuania?
Offer a terse response. -10.56. In the year 1992, what is the difference between the Area (in %) of Jordan and Area (in %) of St. Lucia?
Provide a short and direct response. -13.53. In the year 1992, what is the difference between the Area (in %) of Lithuania and Area (in %) of St. Lucia?
Make the answer very short. -2.97. In the year 1993, what is the difference between the Area (in %) in Italy and Area (in %) in Jordan?
Provide a succinct answer. 6.44. In the year 1993, what is the difference between the Area (in %) of Italy and Area (in %) of Lithuania?
Your answer should be very brief. -3.8. In the year 1993, what is the difference between the Area (in %) in Italy and Area (in %) in St. Lucia?
Your answer should be very brief. -6.77. In the year 1993, what is the difference between the Area (in %) of Jordan and Area (in %) of Lithuania?
Your response must be concise. -10.24. In the year 1993, what is the difference between the Area (in %) in Jordan and Area (in %) in St. Lucia?
Keep it short and to the point. -13.21. In the year 1993, what is the difference between the Area (in %) of Lithuania and Area (in %) of St. Lucia?
Keep it short and to the point. -2.97. In the year 1994, what is the difference between the Area (in %) in Italy and Area (in %) in Jordan?
Keep it short and to the point. 6.49. In the year 1994, what is the difference between the Area (in %) of Italy and Area (in %) of Lithuania?
Give a very brief answer. -3.75. In the year 1994, what is the difference between the Area (in %) of Italy and Area (in %) of St. Lucia?
Ensure brevity in your answer.  -6.72. In the year 1994, what is the difference between the Area (in %) in Jordan and Area (in %) in Lithuania?
Your answer should be compact. -10.24. In the year 1994, what is the difference between the Area (in %) of Jordan and Area (in %) of St. Lucia?
Provide a succinct answer. -13.21. In the year 1994, what is the difference between the Area (in %) in Lithuania and Area (in %) in St. Lucia?
Your answer should be very brief. -2.97. In the year 1995, what is the difference between the Area (in %) in Italy and Area (in %) in Jordan?
Make the answer very short. 6.82. In the year 1995, what is the difference between the Area (in %) in Italy and Area (in %) in Lithuania?
Provide a succinct answer. -3.42. In the year 1995, what is the difference between the Area (in %) of Italy and Area (in %) of St. Lucia?
Your answer should be very brief. -6.39. In the year 1995, what is the difference between the Area (in %) of Jordan and Area (in %) of Lithuania?
Offer a terse response. -10.24. In the year 1995, what is the difference between the Area (in %) of Jordan and Area (in %) of St. Lucia?
Your response must be concise. -13.21. In the year 1995, what is the difference between the Area (in %) of Lithuania and Area (in %) of St. Lucia?
Keep it short and to the point. -2.97. In the year 1996, what is the difference between the Area (in %) in Italy and Area (in %) in Jordan?
Offer a terse response. 6.23. In the year 1996, what is the difference between the Area (in %) of Italy and Area (in %) of Lithuania?
Offer a terse response. -3.2. In the year 1996, what is the difference between the Area (in %) in Italy and Area (in %) in St. Lucia?
Your response must be concise. -6.16. In the year 1996, what is the difference between the Area (in %) of Jordan and Area (in %) of Lithuania?
Provide a succinct answer. -9.43. In the year 1996, what is the difference between the Area (in %) in Jordan and Area (in %) in St. Lucia?
Ensure brevity in your answer.  -12.39. In the year 1996, what is the difference between the Area (in %) in Lithuania and Area (in %) in St. Lucia?
Make the answer very short. -2.97. In the year 1997, what is the difference between the Area (in %) in Italy and Area (in %) in Jordan?
Ensure brevity in your answer.  6.68. In the year 1997, what is the difference between the Area (in %) of Italy and Area (in %) of Lithuania?
Offer a very short reply. -2.74. In the year 1997, what is the difference between the Area (in %) in Italy and Area (in %) in St. Lucia?
Provide a short and direct response. -5.71. In the year 1997, what is the difference between the Area (in %) of Jordan and Area (in %) of Lithuania?
Keep it short and to the point. -9.42. In the year 1997, what is the difference between the Area (in %) in Jordan and Area (in %) in St. Lucia?
Give a very brief answer. -12.38. In the year 1997, what is the difference between the Area (in %) in Lithuania and Area (in %) in St. Lucia?
Offer a very short reply. -2.97. In the year 1998, what is the difference between the Area (in %) of Italy and Area (in %) of Jordan?
Offer a terse response. 7.03. In the year 1998, what is the difference between the Area (in %) of Italy and Area (in %) of Lithuania?
Offer a terse response. -2.52. In the year 1998, what is the difference between the Area (in %) in Italy and Area (in %) in St. Lucia?
Provide a short and direct response. -5.36. In the year 1998, what is the difference between the Area (in %) in Jordan and Area (in %) in Lithuania?
Your answer should be very brief. -9.55. In the year 1998, what is the difference between the Area (in %) in Jordan and Area (in %) in St. Lucia?
Your answer should be very brief. -12.38. In the year 1998, what is the difference between the Area (in %) in Lithuania and Area (in %) in St. Lucia?
Your answer should be compact. -2.84. What is the ratio of the Area (in %) of Jordan in 1991 to that in 1992?
Your answer should be compact. 1. What is the ratio of the Area (in %) in Lithuania in 1991 to that in 1992?
Provide a short and direct response. 0.31. What is the ratio of the Area (in %) of St. Lucia in 1991 to that in 1992?
Offer a very short reply. 1. What is the ratio of the Area (in %) in Italy in 1991 to that in 1993?
Provide a short and direct response. 0.89. What is the ratio of the Area (in %) in Jordan in 1991 to that in 1993?
Your answer should be very brief. 0.69. What is the ratio of the Area (in %) of Lithuania in 1991 to that in 1993?
Your answer should be very brief. 0.31. What is the ratio of the Area (in %) in St. Lucia in 1991 to that in 1993?
Provide a short and direct response. 1. What is the ratio of the Area (in %) in Italy in 1991 to that in 1994?
Ensure brevity in your answer.  0.89. What is the ratio of the Area (in %) of Jordan in 1991 to that in 1994?
Provide a succinct answer. 0.69. What is the ratio of the Area (in %) of Lithuania in 1991 to that in 1994?
Ensure brevity in your answer.  0.31. What is the ratio of the Area (in %) in Italy in 1991 to that in 1995?
Give a very brief answer. 0.85. What is the ratio of the Area (in %) of Jordan in 1991 to that in 1995?
Keep it short and to the point. 0.69. What is the ratio of the Area (in %) in Lithuania in 1991 to that in 1995?
Give a very brief answer. 0.31. What is the ratio of the Area (in %) in Italy in 1991 to that in 1996?
Provide a short and direct response. 0.83. What is the ratio of the Area (in %) of Jordan in 1991 to that in 1996?
Provide a succinct answer. 0.39. What is the ratio of the Area (in %) in Lithuania in 1991 to that in 1996?
Give a very brief answer. 0.31. What is the ratio of the Area (in %) in St. Lucia in 1991 to that in 1996?
Your response must be concise. 1. What is the ratio of the Area (in %) of Italy in 1991 to that in 1997?
Keep it short and to the point. 0.78. What is the ratio of the Area (in %) in Jordan in 1991 to that in 1997?
Keep it short and to the point. 0.39. What is the ratio of the Area (in %) in Lithuania in 1991 to that in 1997?
Keep it short and to the point. 0.31. What is the ratio of the Area (in %) of Italy in 1991 to that in 1998?
Provide a succinct answer. 0.75. What is the ratio of the Area (in %) in Jordan in 1991 to that in 1998?
Provide a short and direct response. 0.39. What is the ratio of the Area (in %) in Lithuania in 1991 to that in 1998?
Your answer should be very brief. 0.31. What is the ratio of the Area (in %) of St. Lucia in 1991 to that in 1998?
Your response must be concise. 1. What is the ratio of the Area (in %) in Italy in 1992 to that in 1993?
Keep it short and to the point. 0.9. What is the ratio of the Area (in %) of Jordan in 1992 to that in 1993?
Provide a succinct answer. 0.69. What is the ratio of the Area (in %) in Lithuania in 1992 to that in 1993?
Your answer should be compact. 1. What is the ratio of the Area (in %) in St. Lucia in 1992 to that in 1993?
Make the answer very short. 1. What is the ratio of the Area (in %) in Italy in 1992 to that in 1994?
Make the answer very short. 0.89. What is the ratio of the Area (in %) in Jordan in 1992 to that in 1994?
Ensure brevity in your answer.  0.69. What is the ratio of the Area (in %) of St. Lucia in 1992 to that in 1994?
Offer a terse response. 1. What is the ratio of the Area (in %) in Italy in 1992 to that in 1995?
Offer a very short reply. 0.85. What is the ratio of the Area (in %) in Jordan in 1992 to that in 1995?
Keep it short and to the point. 0.69. What is the ratio of the Area (in %) in Lithuania in 1992 to that in 1995?
Give a very brief answer. 1. What is the ratio of the Area (in %) of St. Lucia in 1992 to that in 1995?
Provide a short and direct response. 1. What is the ratio of the Area (in %) in Italy in 1992 to that in 1996?
Offer a very short reply. 0.83. What is the ratio of the Area (in %) of Jordan in 1992 to that in 1996?
Your answer should be compact. 0.39. What is the ratio of the Area (in %) in Lithuania in 1992 to that in 1996?
Offer a very short reply. 1. What is the ratio of the Area (in %) in Italy in 1992 to that in 1997?
Your answer should be very brief. 0.79. What is the ratio of the Area (in %) in Jordan in 1992 to that in 1997?
Offer a terse response. 0.39. What is the ratio of the Area (in %) of St. Lucia in 1992 to that in 1997?
Your answer should be compact. 1. What is the ratio of the Area (in %) of Italy in 1992 to that in 1998?
Offer a very short reply. 0.76. What is the ratio of the Area (in %) of Jordan in 1992 to that in 1998?
Ensure brevity in your answer.  0.39. What is the ratio of the Area (in %) of Italy in 1993 to that in 1994?
Your answer should be very brief. 0.99. What is the ratio of the Area (in %) of Jordan in 1993 to that in 1994?
Make the answer very short. 1. What is the ratio of the Area (in %) in Jordan in 1993 to that in 1995?
Your response must be concise. 1. What is the ratio of the Area (in %) of Lithuania in 1993 to that in 1995?
Keep it short and to the point. 1. What is the ratio of the Area (in %) of Italy in 1993 to that in 1996?
Your answer should be compact. 0.93. What is the ratio of the Area (in %) in Jordan in 1993 to that in 1996?
Provide a short and direct response. 0.56. What is the ratio of the Area (in %) of St. Lucia in 1993 to that in 1996?
Offer a terse response. 1. What is the ratio of the Area (in %) in Italy in 1993 to that in 1997?
Offer a very short reply. 0.88. What is the ratio of the Area (in %) in Jordan in 1993 to that in 1997?
Give a very brief answer. 0.56. What is the ratio of the Area (in %) of Lithuania in 1993 to that in 1997?
Give a very brief answer. 1. What is the ratio of the Area (in %) of St. Lucia in 1993 to that in 1997?
Your answer should be very brief. 1. What is the ratio of the Area (in %) of Italy in 1993 to that in 1998?
Provide a short and direct response. 0.84. What is the ratio of the Area (in %) in Jordan in 1993 to that in 1998?
Keep it short and to the point. 0.56. What is the ratio of the Area (in %) in St. Lucia in 1993 to that in 1998?
Give a very brief answer. 1. What is the ratio of the Area (in %) in Lithuania in 1994 to that in 1995?
Your answer should be very brief. 1. What is the ratio of the Area (in %) in Italy in 1994 to that in 1996?
Your answer should be very brief. 0.93. What is the ratio of the Area (in %) in Jordan in 1994 to that in 1996?
Your answer should be very brief. 0.56. What is the ratio of the Area (in %) of Lithuania in 1994 to that in 1996?
Offer a terse response. 1. What is the ratio of the Area (in %) in St. Lucia in 1994 to that in 1996?
Ensure brevity in your answer.  1. What is the ratio of the Area (in %) of Italy in 1994 to that in 1997?
Make the answer very short. 0.88. What is the ratio of the Area (in %) of Jordan in 1994 to that in 1997?
Offer a very short reply. 0.56. What is the ratio of the Area (in %) in Lithuania in 1994 to that in 1997?
Give a very brief answer. 1. What is the ratio of the Area (in %) in St. Lucia in 1994 to that in 1997?
Your answer should be compact. 1. What is the ratio of the Area (in %) of Italy in 1994 to that in 1998?
Provide a succinct answer. 0.85. What is the ratio of the Area (in %) of Jordan in 1994 to that in 1998?
Your answer should be very brief. 0.56. What is the ratio of the Area (in %) of Lithuania in 1994 to that in 1998?
Your answer should be very brief. 0.99. What is the ratio of the Area (in %) in Italy in 1995 to that in 1996?
Your response must be concise. 0.97. What is the ratio of the Area (in %) in Jordan in 1995 to that in 1996?
Your response must be concise. 0.56. What is the ratio of the Area (in %) of Lithuania in 1995 to that in 1996?
Give a very brief answer. 1. What is the ratio of the Area (in %) in Italy in 1995 to that in 1997?
Keep it short and to the point. 0.92. What is the ratio of the Area (in %) in Jordan in 1995 to that in 1997?
Provide a succinct answer. 0.56. What is the ratio of the Area (in %) of Lithuania in 1995 to that in 1997?
Provide a short and direct response. 1. What is the ratio of the Area (in %) in St. Lucia in 1995 to that in 1997?
Your answer should be compact. 1. What is the ratio of the Area (in %) in Italy in 1995 to that in 1998?
Make the answer very short. 0.88. What is the ratio of the Area (in %) of Jordan in 1995 to that in 1998?
Your response must be concise. 0.56. What is the ratio of the Area (in %) of Lithuania in 1995 to that in 1998?
Ensure brevity in your answer.  0.99. What is the ratio of the Area (in %) of Italy in 1996 to that in 1997?
Provide a succinct answer. 0.95. What is the ratio of the Area (in %) in Jordan in 1996 to that in 1997?
Provide a succinct answer. 1. What is the ratio of the Area (in %) in Lithuania in 1996 to that in 1997?
Your response must be concise. 1. What is the ratio of the Area (in %) in St. Lucia in 1996 to that in 1997?
Keep it short and to the point. 1. What is the ratio of the Area (in %) in Italy in 1996 to that in 1998?
Provide a succinct answer. 0.91. What is the ratio of the Area (in %) of Lithuania in 1996 to that in 1998?
Offer a very short reply. 0.99. What is the ratio of the Area (in %) of Italy in 1997 to that in 1998?
Your response must be concise. 0.96. What is the ratio of the Area (in %) in Lithuania in 1997 to that in 1998?
Make the answer very short. 0.99. What is the difference between the highest and the second highest Area (in %) in Italy?
Make the answer very short. 0.35. What is the difference between the highest and the second highest Area (in %) in Jordan?
Offer a terse response. 0. What is the difference between the highest and the second highest Area (in %) in Lithuania?
Give a very brief answer. 0.13. What is the difference between the highest and the second highest Area (in %) in St. Lucia?
Provide a short and direct response. 0. What is the difference between the highest and the lowest Area (in %) in Italy?
Your response must be concise. 2.2. What is the difference between the highest and the lowest Area (in %) of Jordan?
Keep it short and to the point. 1.15. What is the difference between the highest and the lowest Area (in %) in Lithuania?
Give a very brief answer. 7.87. 